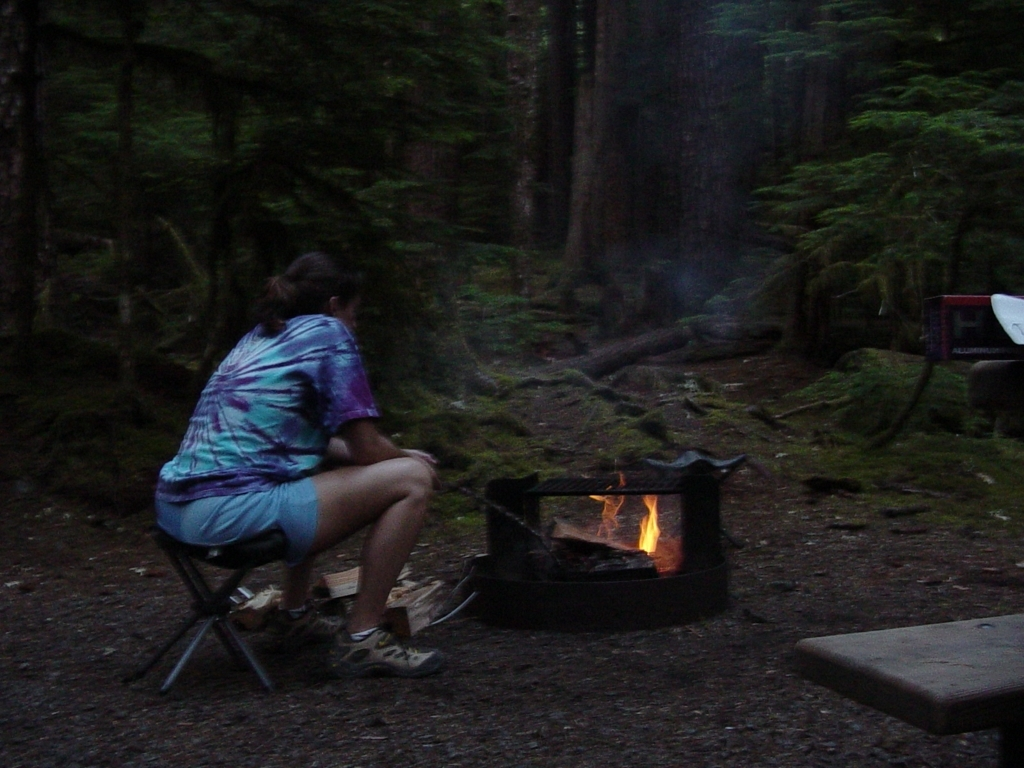Could you describe the atmosphere or mood of the setting portrayed in the image? The atmosphere of the image evokes a sense of tranquility and seclusion, commonly associated with a forest camping site. The presence of a fire pit gently illuminating the scene suggests a calm evening, potentially filled with the sounds of the wilderness and the low crackle of the burning wood. 